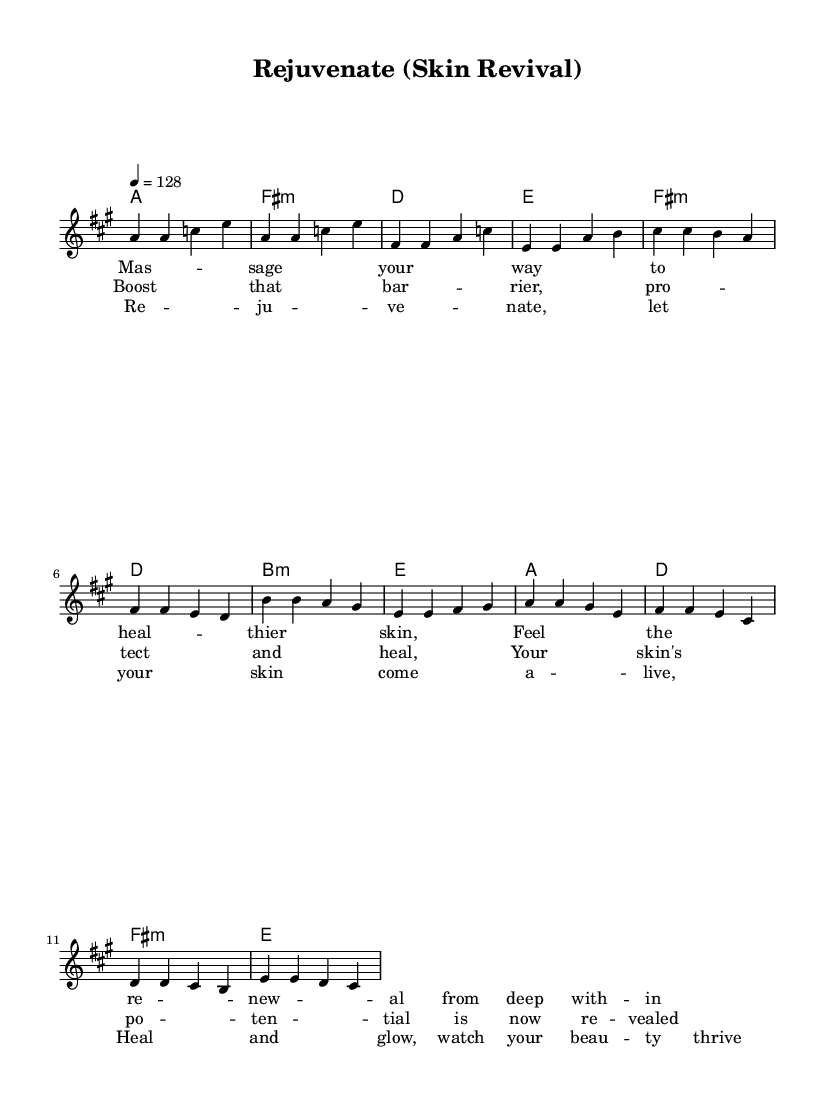What is the key signature of this music? The key signature of the piece is A major, which has three sharps (F#, C#, and G#). This can be determined from the global section where the key is indicated.
Answer: A major What is the time signature of this music? The time signature is 4/4, which means there are four beats in a measure. This can be found in the global section where the time is specified.
Answer: 4/4 What is the tempo marking for this piece? The tempo marking is 128 beats per minute. This is specified in the global section where the tempo is expressed as "4 = 128".
Answer: 128 How many measures are there in the chorus? The chorus consists of four measures, as can be counted directly from the melody section where the corresponding notes for the chorus are placed in four distinct measures.
Answer: 4 What is the first lyric line of the verse? The first lyric line of the verse is “Massage your way to heal their skin”. This can be found in the verse lyrics section where the corresponding notes for the verse are written.
Answer: "Massage your way to heal their skin" Which chord is used in the first measure of the pre-chorus? The chord used in the first measure of the pre-chorus is F# minor, as indicated in the harmonies section where the chord for this measure is specified.
Answer: F# minor What is the repeated theme in the chorus lyrics? The repeated theme refers to the idea of rejuvenation and healing, as expressed in the lyrics "Rejuvenate, let your skin come alive". This highlights the uplifting and positive essence tied to skin care.
Answer: Rejuvenation and healing 